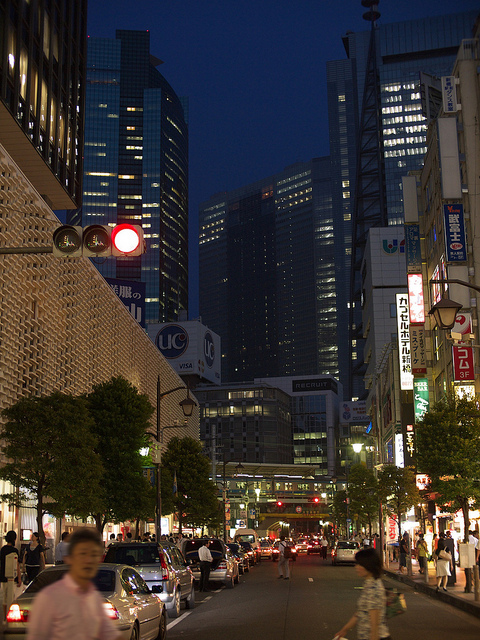Identify the text contained in this image. UC 3 F 